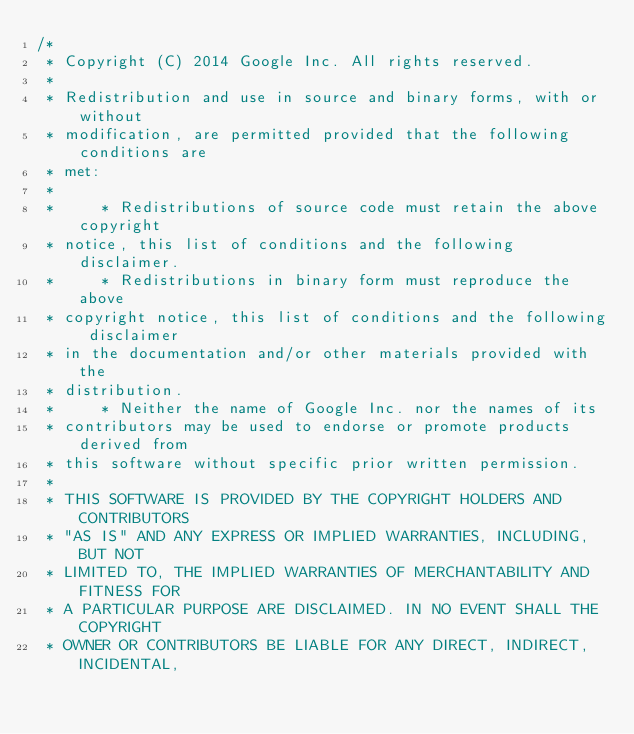<code> <loc_0><loc_0><loc_500><loc_500><_C_>/*
 * Copyright (C) 2014 Google Inc. All rights reserved.
 *
 * Redistribution and use in source and binary forms, with or without
 * modification, are permitted provided that the following conditions are
 * met:
 *
 *     * Redistributions of source code must retain the above copyright
 * notice, this list of conditions and the following disclaimer.
 *     * Redistributions in binary form must reproduce the above
 * copyright notice, this list of conditions and the following disclaimer
 * in the documentation and/or other materials provided with the
 * distribution.
 *     * Neither the name of Google Inc. nor the names of its
 * contributors may be used to endorse or promote products derived from
 * this software without specific prior written permission.
 *
 * THIS SOFTWARE IS PROVIDED BY THE COPYRIGHT HOLDERS AND CONTRIBUTORS
 * "AS IS" AND ANY EXPRESS OR IMPLIED WARRANTIES, INCLUDING, BUT NOT
 * LIMITED TO, THE IMPLIED WARRANTIES OF MERCHANTABILITY AND FITNESS FOR
 * A PARTICULAR PURPOSE ARE DISCLAIMED. IN NO EVENT SHALL THE COPYRIGHT
 * OWNER OR CONTRIBUTORS BE LIABLE FOR ANY DIRECT, INDIRECT, INCIDENTAL,</code> 